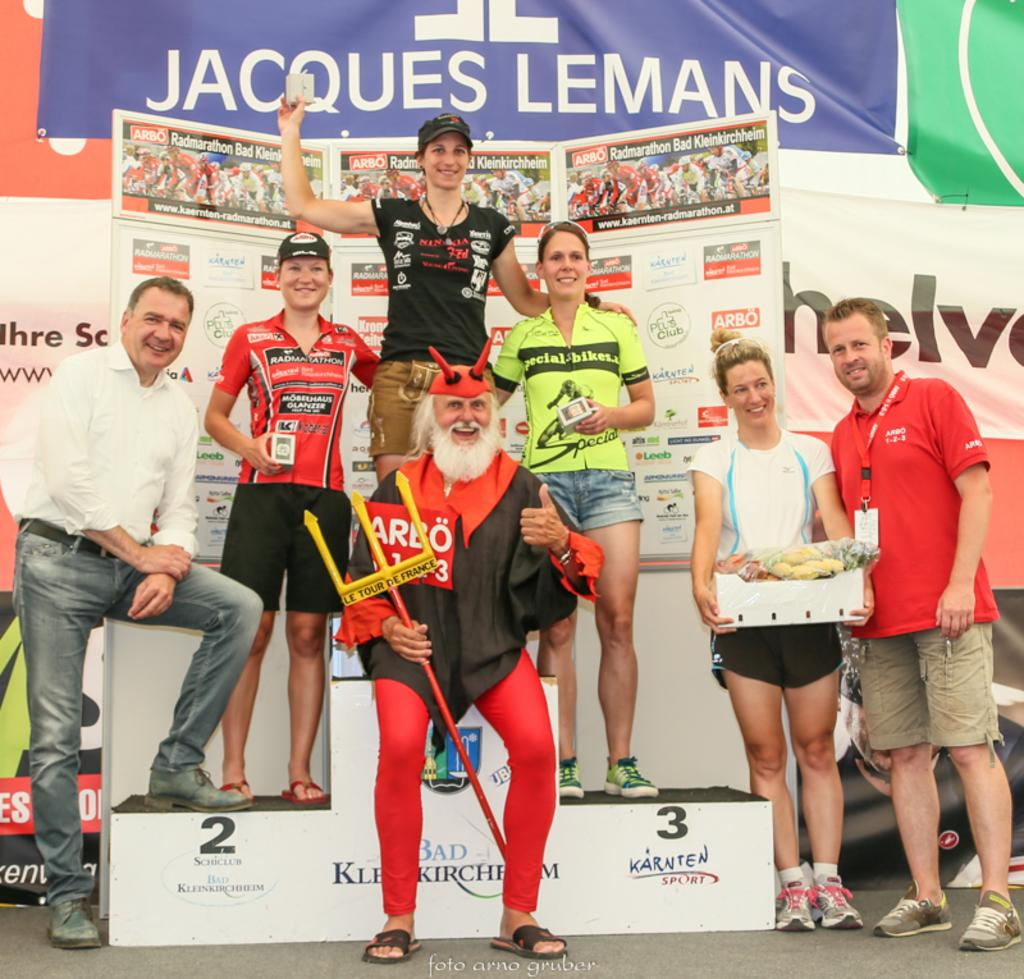<image>
Present a compact description of the photo's key features. People pose for a picture with a man dressed up and with a prop in his hand that reads, "Le Tour De France". 